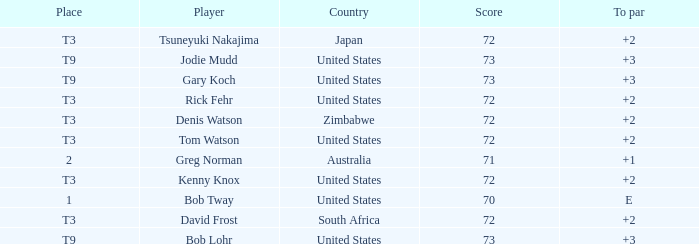What is the top score for tsuneyuki nakajima? 72.0. 